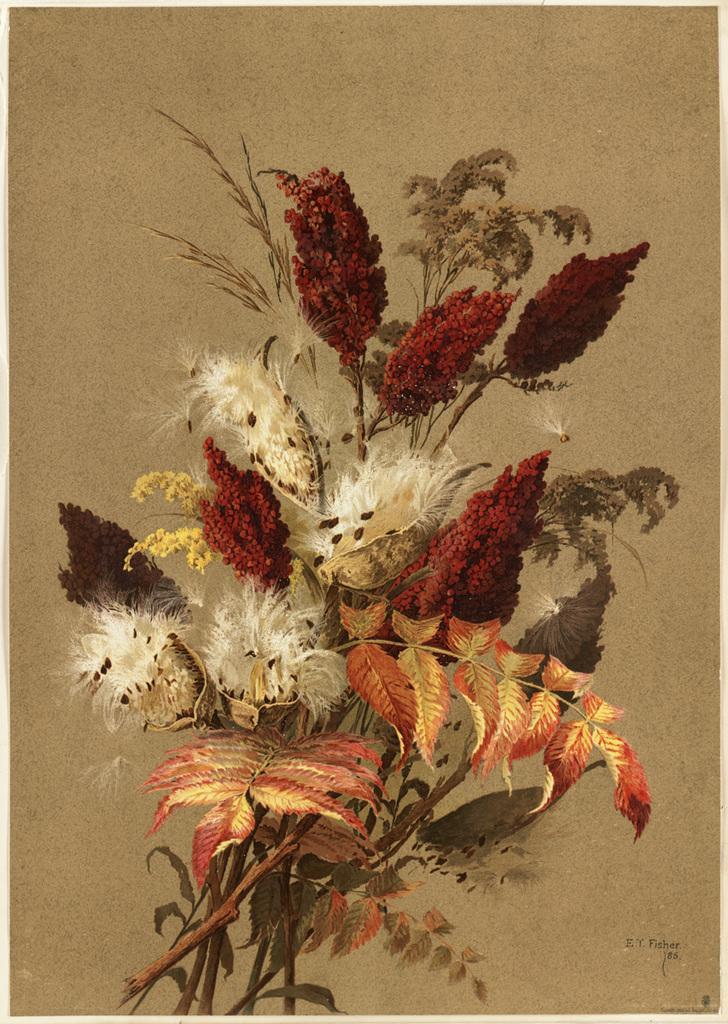How would you summarize this image in a sentence or two? By seeing this image we can say it is a painting. In this painting we can see bouquet which have leaves and flowers. 